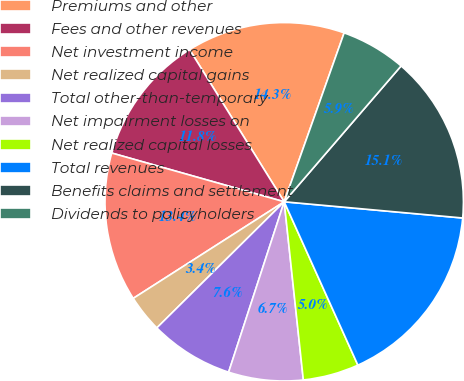Convert chart to OTSL. <chart><loc_0><loc_0><loc_500><loc_500><pie_chart><fcel>Premiums and other<fcel>Fees and other revenues<fcel>Net investment income<fcel>Net realized capital gains<fcel>Total other-than-temporary<fcel>Net impairment losses on<fcel>Net realized capital losses<fcel>Total revenues<fcel>Benefits claims and settlement<fcel>Dividends to policyholders<nl><fcel>14.28%<fcel>11.76%<fcel>13.44%<fcel>3.36%<fcel>7.56%<fcel>6.72%<fcel>5.04%<fcel>16.81%<fcel>15.13%<fcel>5.88%<nl></chart> 